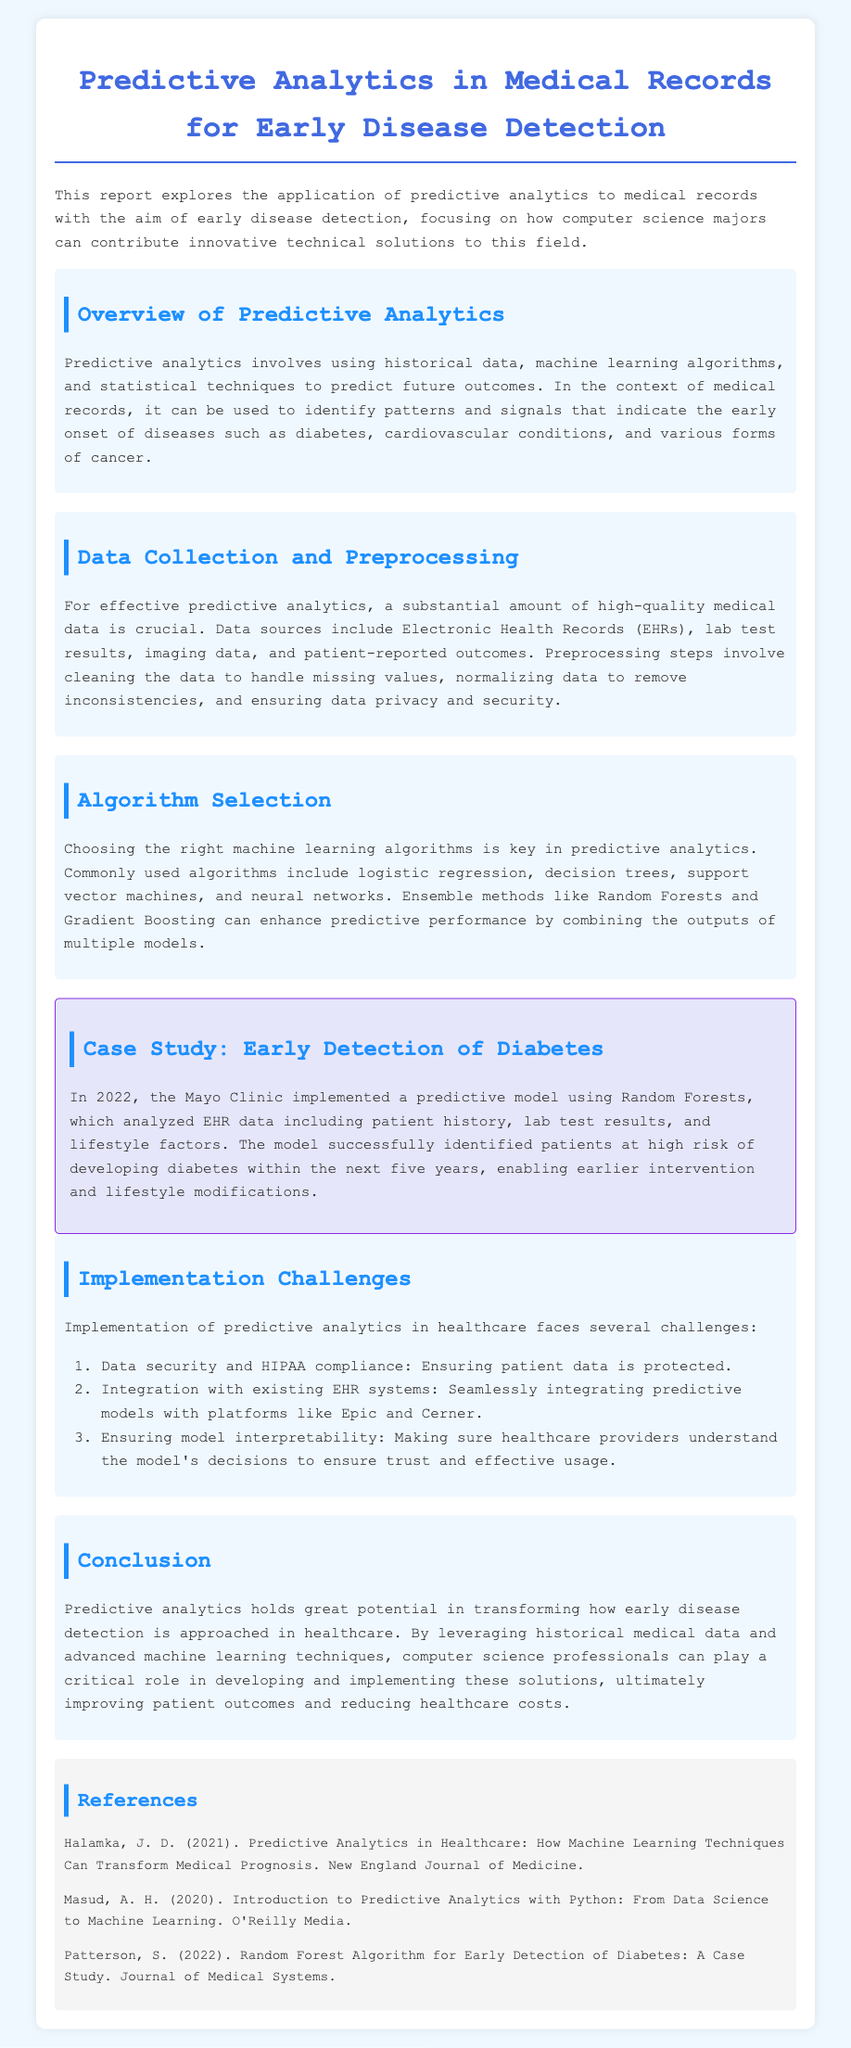What is the title of the document? The title is found in the header of the document and describes the main focus of the report.
Answer: Predictive Analytics in Medical Records for Early Disease Detection What year did the Mayo Clinic implement the predictive model? The document specifies the year in which the case study regarding diabetes detection was conducted.
Answer: 2022 What is a key challenge of implementing predictive analytics mentioned in the document? The document lists several challenges in the section on implementation obstacles, and this is one such challenge.
Answer: Data security and HIPAA compliance Which algorithm was used in the case study for early detection of diabetes? The document details the specific algorithm utilized in the case study to analyze medical data for detecting diabetes.
Answer: Random Forests What is the main purpose of predictive analytics in healthcare? The document clarifies the primary aim of using predictive analytics in medical records, particularly in early detection of diseases.
Answer: Early disease detection Which type of data is crucial for effective predictive analytics? The document lists the types of data that are essential for conducting predictive analytics within medical records.
Answer: High-quality medical data What does the section on 'Algorithm Selection' emphasize? The document summarizes the importance of choosing the right machine learning algorithms within the context of predictive analytics.
Answer: Choosing the right machine learning algorithms What does the document suggest about the role of computer science professionals? The conclusion of the document indicates how computer science professionals can contribute to the field of predictive analytics in healthcare.
Answer: Developing and implementing solutions 